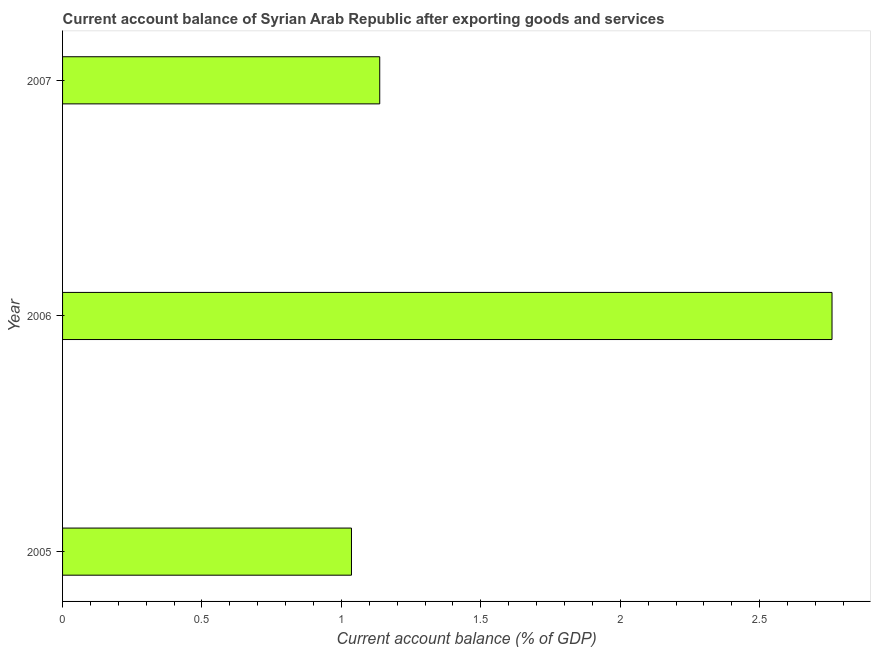Does the graph contain any zero values?
Provide a short and direct response. No. What is the title of the graph?
Offer a terse response. Current account balance of Syrian Arab Republic after exporting goods and services. What is the label or title of the X-axis?
Make the answer very short. Current account balance (% of GDP). What is the current account balance in 2005?
Provide a short and direct response. 1.04. Across all years, what is the maximum current account balance?
Your answer should be compact. 2.76. Across all years, what is the minimum current account balance?
Your answer should be very brief. 1.04. What is the sum of the current account balance?
Ensure brevity in your answer.  4.93. What is the difference between the current account balance in 2005 and 2007?
Ensure brevity in your answer.  -0.1. What is the average current account balance per year?
Your answer should be very brief. 1.64. What is the median current account balance?
Offer a terse response. 1.14. In how many years, is the current account balance greater than 1.8 %?
Your answer should be compact. 1. What is the ratio of the current account balance in 2006 to that in 2007?
Ensure brevity in your answer.  2.43. Is the current account balance in 2006 less than that in 2007?
Provide a short and direct response. No. Is the difference between the current account balance in 2006 and 2007 greater than the difference between any two years?
Offer a very short reply. No. What is the difference between the highest and the second highest current account balance?
Your response must be concise. 1.62. What is the difference between the highest and the lowest current account balance?
Provide a succinct answer. 1.72. In how many years, is the current account balance greater than the average current account balance taken over all years?
Provide a short and direct response. 1. Are all the bars in the graph horizontal?
Provide a short and direct response. Yes. How many years are there in the graph?
Offer a very short reply. 3. What is the difference between two consecutive major ticks on the X-axis?
Ensure brevity in your answer.  0.5. Are the values on the major ticks of X-axis written in scientific E-notation?
Provide a succinct answer. No. What is the Current account balance (% of GDP) in 2005?
Keep it short and to the point. 1.04. What is the Current account balance (% of GDP) in 2006?
Ensure brevity in your answer.  2.76. What is the Current account balance (% of GDP) in 2007?
Provide a succinct answer. 1.14. What is the difference between the Current account balance (% of GDP) in 2005 and 2006?
Provide a short and direct response. -1.72. What is the difference between the Current account balance (% of GDP) in 2005 and 2007?
Provide a short and direct response. -0.1. What is the difference between the Current account balance (% of GDP) in 2006 and 2007?
Provide a short and direct response. 1.62. What is the ratio of the Current account balance (% of GDP) in 2005 to that in 2006?
Your answer should be compact. 0.38. What is the ratio of the Current account balance (% of GDP) in 2005 to that in 2007?
Offer a very short reply. 0.91. What is the ratio of the Current account balance (% of GDP) in 2006 to that in 2007?
Give a very brief answer. 2.43. 